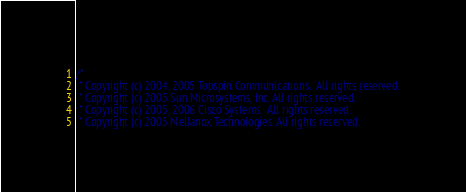Convert code to text. <code><loc_0><loc_0><loc_500><loc_500><_C_>/*
 * Copyright (c) 2004, 2005 Topspin Communications.  All rights reserved.
 * Copyright (c) 2005 Sun Microsystems, Inc. All rights reserved.
 * Copyright (c) 2005, 2006 Cisco Systems.  All rights reserved.
 * Copyright (c) 2005 Mellanox Technologies. All rights reserved.</code> 